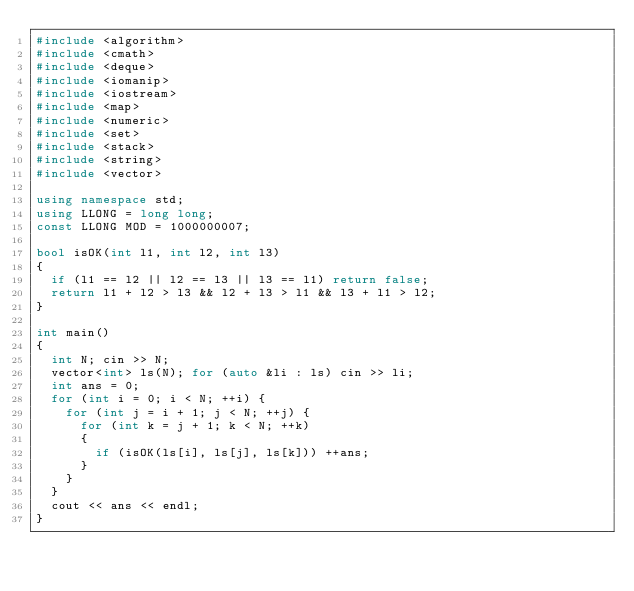Convert code to text. <code><loc_0><loc_0><loc_500><loc_500><_C++_>#include <algorithm>
#include <cmath>
#include <deque>
#include <iomanip>
#include <iostream>
#include <map>
#include <numeric>
#include <set>
#include <stack>
#include <string>
#include <vector>

using namespace std;
using LLONG = long long;
const LLONG MOD = 1000000007;

bool isOK(int l1, int l2, int l3)
{
	if (l1 == l2 || l2 == l3 || l3 == l1) return false;
	return l1 + l2 > l3 && l2 + l3 > l1 && l3 + l1 > l2;
}

int main()
{
	int N; cin >> N;
	vector<int> ls(N); for (auto &li : ls) cin >> li;
	int ans = 0;
	for (int i = 0; i < N; ++i) {
		for (int j = i + 1; j < N; ++j) {
			for (int k = j + 1; k < N; ++k)
			{
				if (isOK(ls[i], ls[j], ls[k])) ++ans;
			}
		}
	}
	cout << ans << endl;
}
</code> 